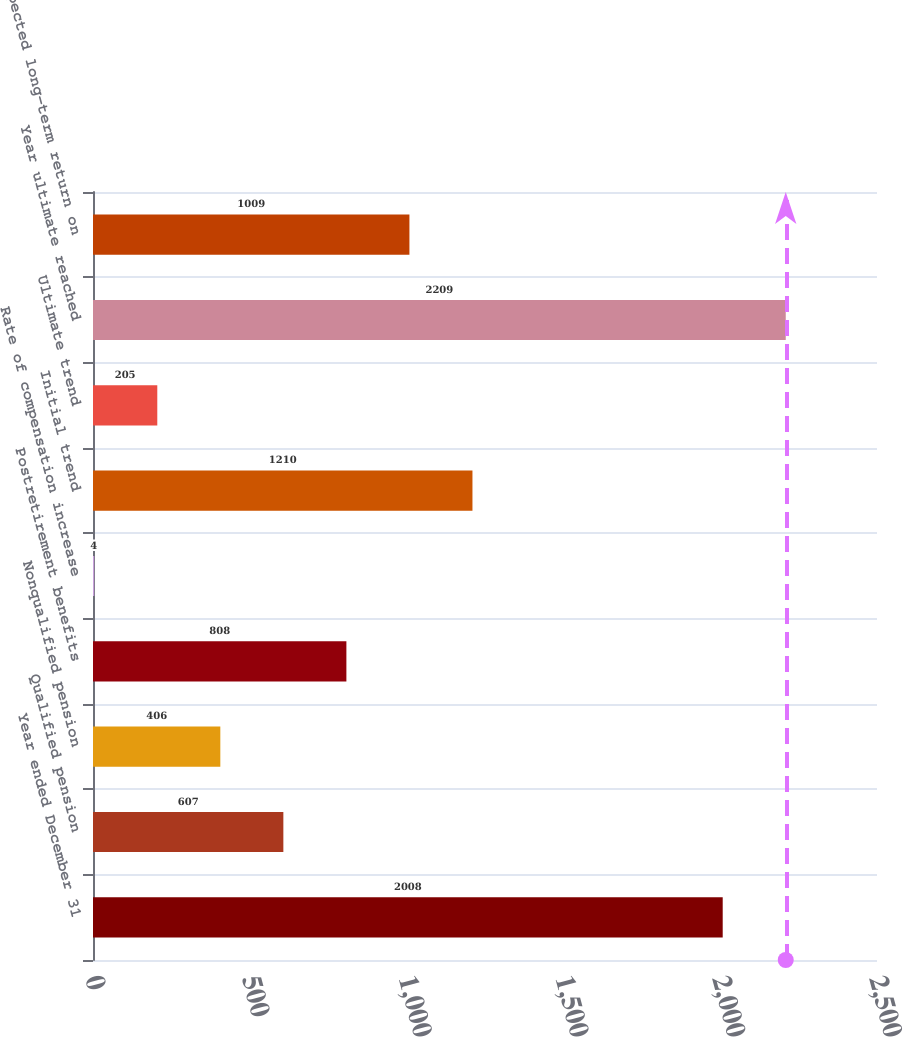Convert chart. <chart><loc_0><loc_0><loc_500><loc_500><bar_chart><fcel>Year ended December 31<fcel>Qualified pension<fcel>Nonqualified pension<fcel>Postretirement benefits<fcel>Rate of compensation increase<fcel>Initial trend<fcel>Ultimate trend<fcel>Year ultimate reached<fcel>Expected long-term return on<nl><fcel>2008<fcel>607<fcel>406<fcel>808<fcel>4<fcel>1210<fcel>205<fcel>2209<fcel>1009<nl></chart> 